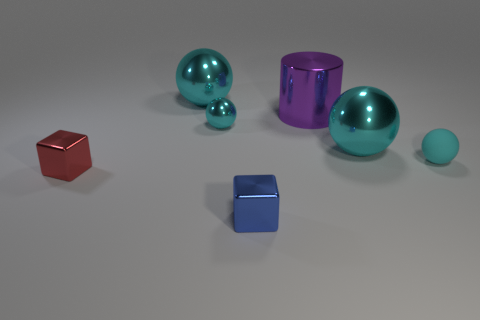Are there more small cyan balls than large yellow matte objects?
Your response must be concise. Yes. Is there a tiny red rubber ball?
Your response must be concise. No. What shape is the large cyan metallic object to the right of the tiny cube that is in front of the tiny red cube?
Provide a short and direct response. Sphere. How many things are either small cyan spheres or spheres that are behind the cyan rubber ball?
Ensure brevity in your answer.  4. There is a big object on the left side of the small object that is behind the small cyan ball that is to the right of the large purple metal object; what color is it?
Your response must be concise. Cyan. What material is the other object that is the same shape as the tiny blue shiny thing?
Offer a terse response. Metal. What is the color of the rubber object?
Your answer should be very brief. Cyan. Is the cylinder the same color as the rubber object?
Your answer should be very brief. No. What number of matte things are either big cyan things or small red cubes?
Your response must be concise. 0. There is a small shiny thing that is behind the cube left of the tiny metal sphere; is there a purple cylinder left of it?
Provide a succinct answer. No. 